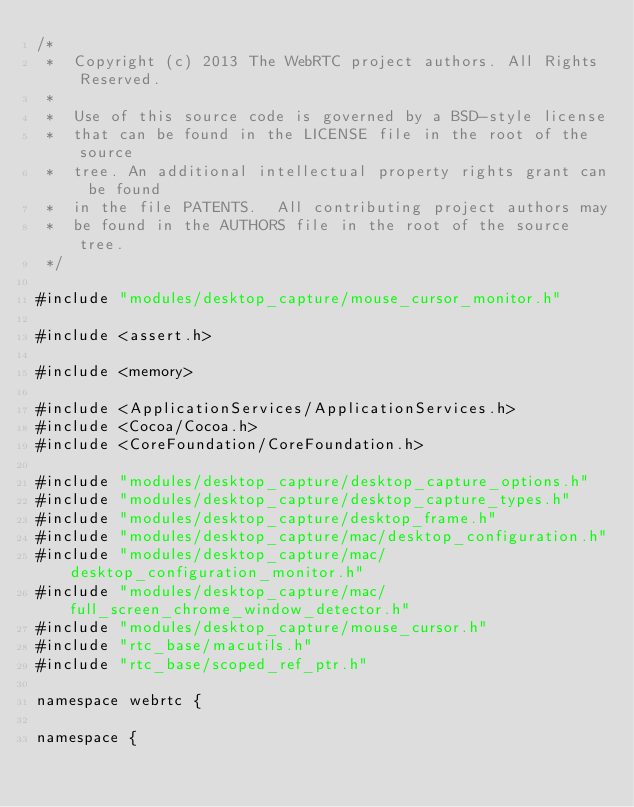<code> <loc_0><loc_0><loc_500><loc_500><_ObjectiveC_>/*
 *  Copyright (c) 2013 The WebRTC project authors. All Rights Reserved.
 *
 *  Use of this source code is governed by a BSD-style license
 *  that can be found in the LICENSE file in the root of the source
 *  tree. An additional intellectual property rights grant can be found
 *  in the file PATENTS.  All contributing project authors may
 *  be found in the AUTHORS file in the root of the source tree.
 */

#include "modules/desktop_capture/mouse_cursor_monitor.h"

#include <assert.h>

#include <memory>

#include <ApplicationServices/ApplicationServices.h>
#include <Cocoa/Cocoa.h>
#include <CoreFoundation/CoreFoundation.h>

#include "modules/desktop_capture/desktop_capture_options.h"
#include "modules/desktop_capture/desktop_capture_types.h"
#include "modules/desktop_capture/desktop_frame.h"
#include "modules/desktop_capture/mac/desktop_configuration.h"
#include "modules/desktop_capture/mac/desktop_configuration_monitor.h"
#include "modules/desktop_capture/mac/full_screen_chrome_window_detector.h"
#include "modules/desktop_capture/mouse_cursor.h"
#include "rtc_base/macutils.h"
#include "rtc_base/scoped_ref_ptr.h"

namespace webrtc {

namespace {</code> 